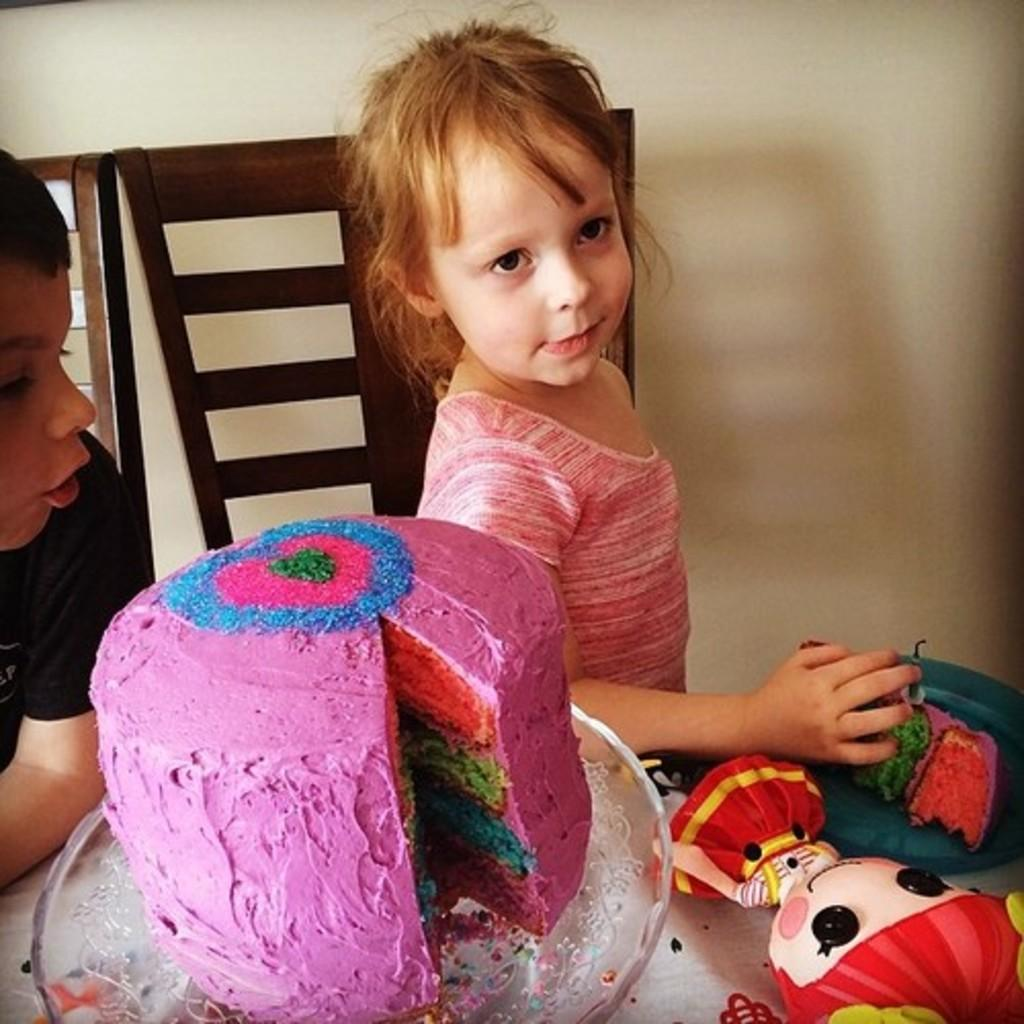What types of objects can be seen in the foreground of the picture? There are toys, a cake, and other objects in the foreground of the picture. What is the main focus in the center of the picture? There are chairs and two kids in the center of the picture. What is the color of the wall at the top of the picture? The wall at the top of the picture is painted white. How does the committee feel about the temper of the icicle in the picture? There is no committee, temper, or icicle present in the picture. 